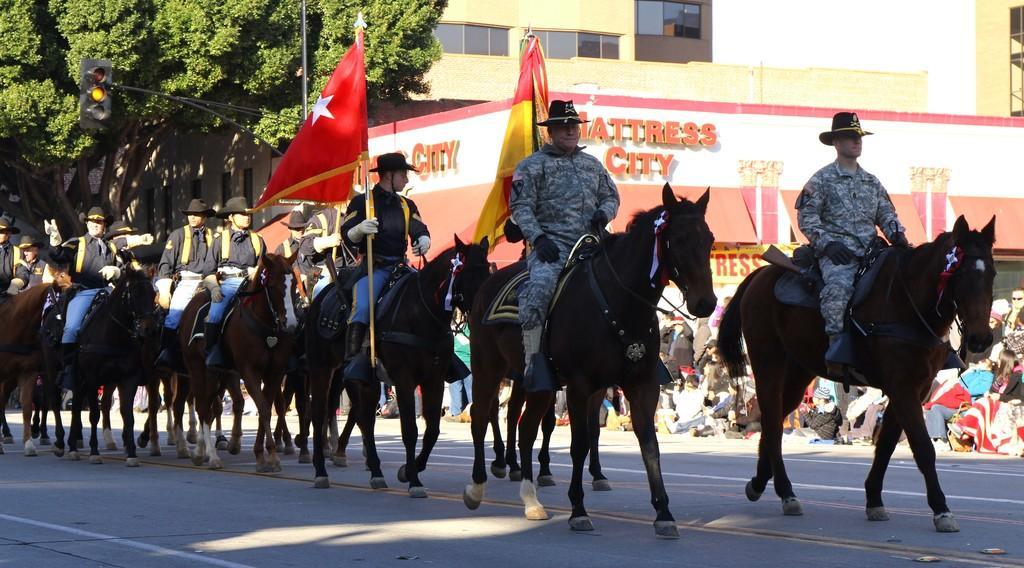Could you give a brief overview of what you see in this image? In the center of the image we can see a few people are riding horses one the road. And we can see they are in different costumes. Among them, we can see two persons are holding flags. In the background there is a building, trees, one banner, one traffic light, sign boards, few people are standing, few people are sitting, few people are holding some objects and a few other objects. 